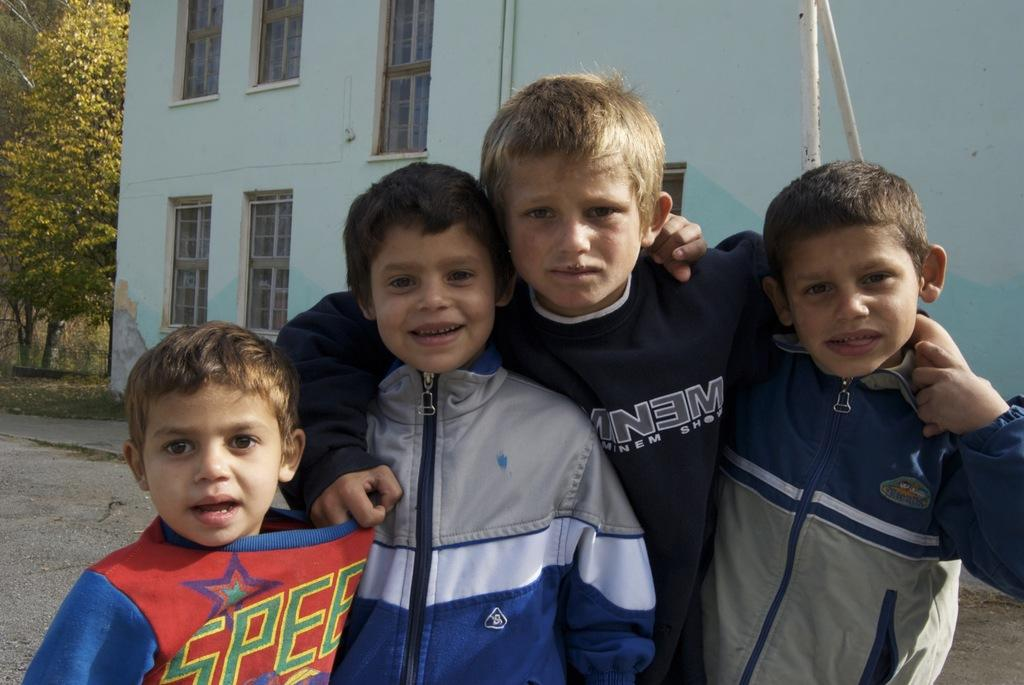Provide a one-sentence caption for the provided image. The tallest of the 4 boys has on a shirt that says something "NEM" but is obscured by another boy. 